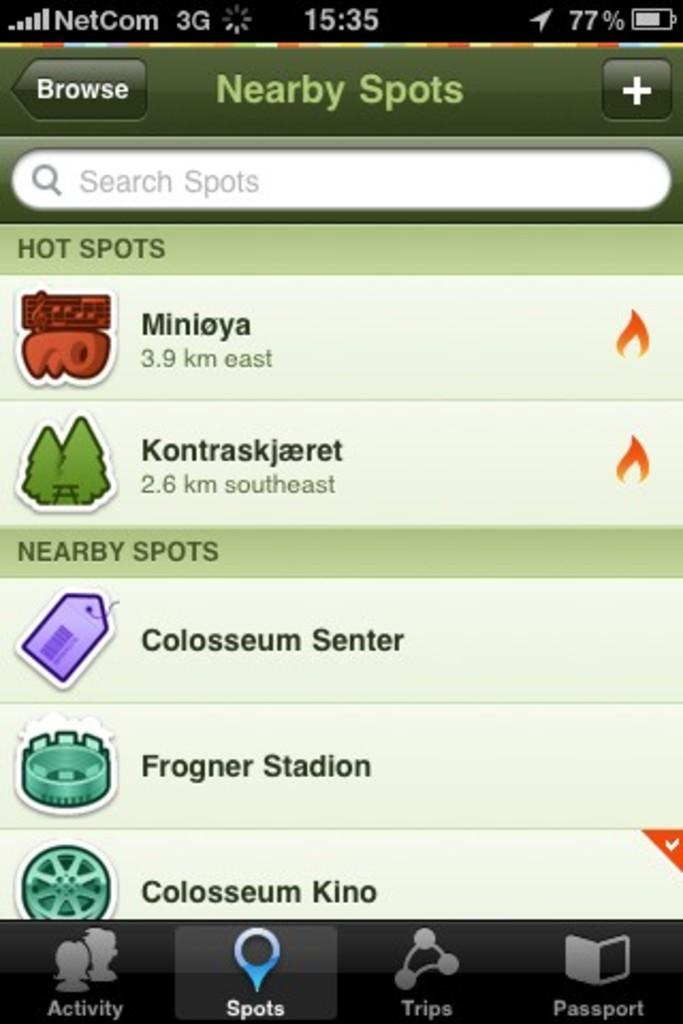<image>
Share a concise interpretation of the image provided. a screencap of nearby spots like stadiums and forests in a foreign language 